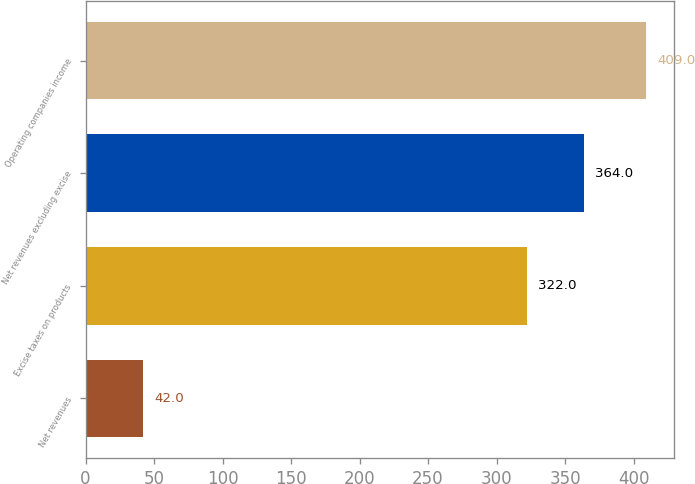Convert chart. <chart><loc_0><loc_0><loc_500><loc_500><bar_chart><fcel>Net revenues<fcel>Excise taxes on products<fcel>Net revenues excluding excise<fcel>Operating companies income<nl><fcel>42<fcel>322<fcel>364<fcel>409<nl></chart> 